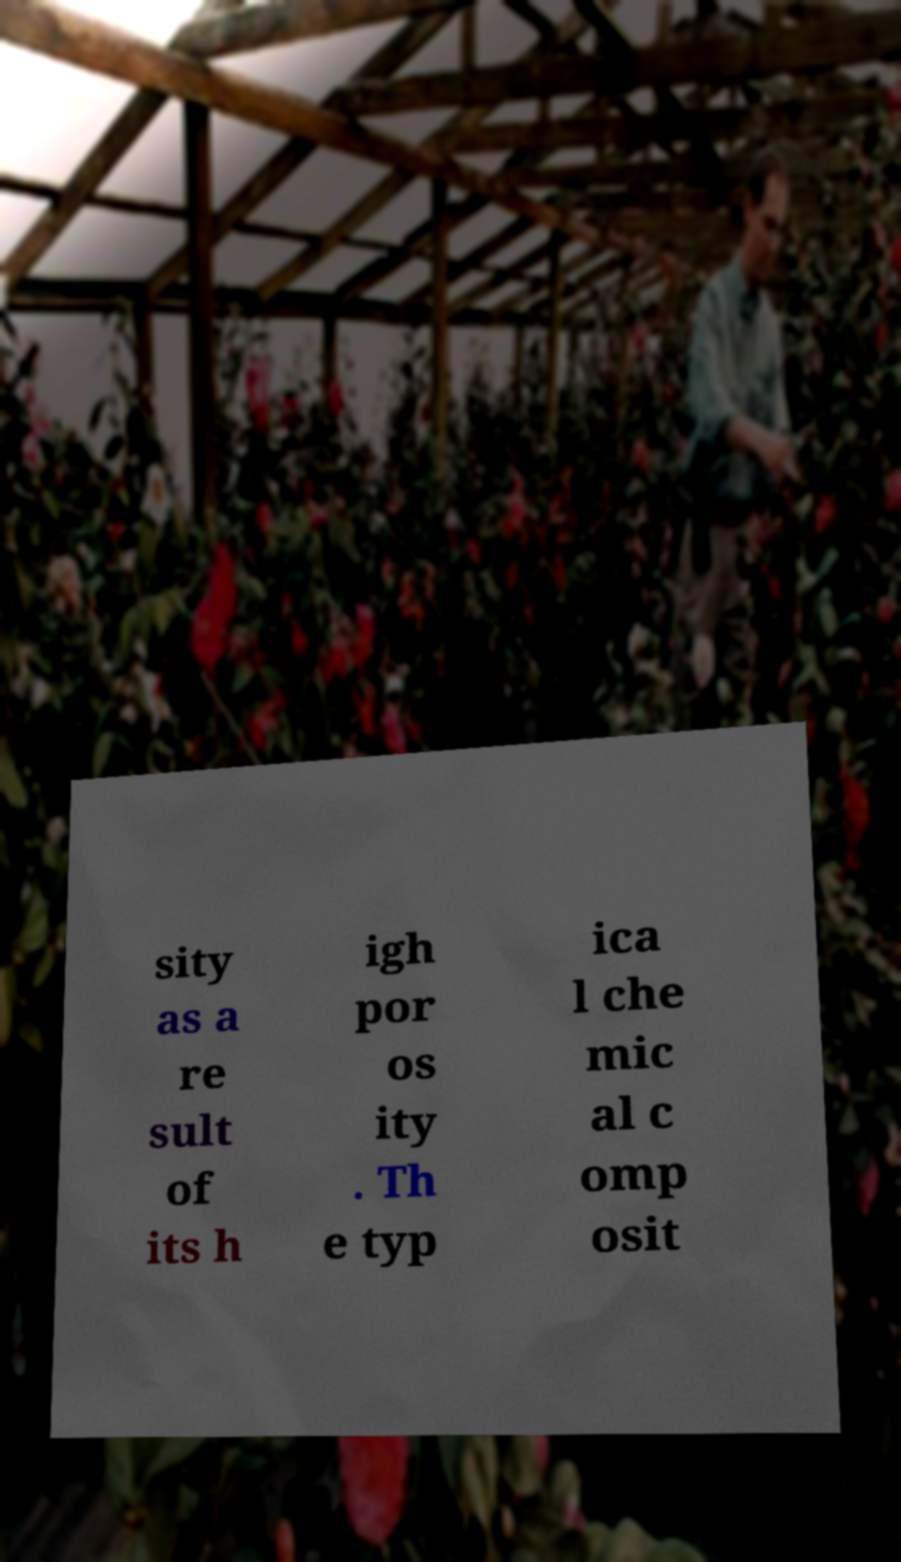Can you accurately transcribe the text from the provided image for me? sity as a re sult of its h igh por os ity . Th e typ ica l che mic al c omp osit 